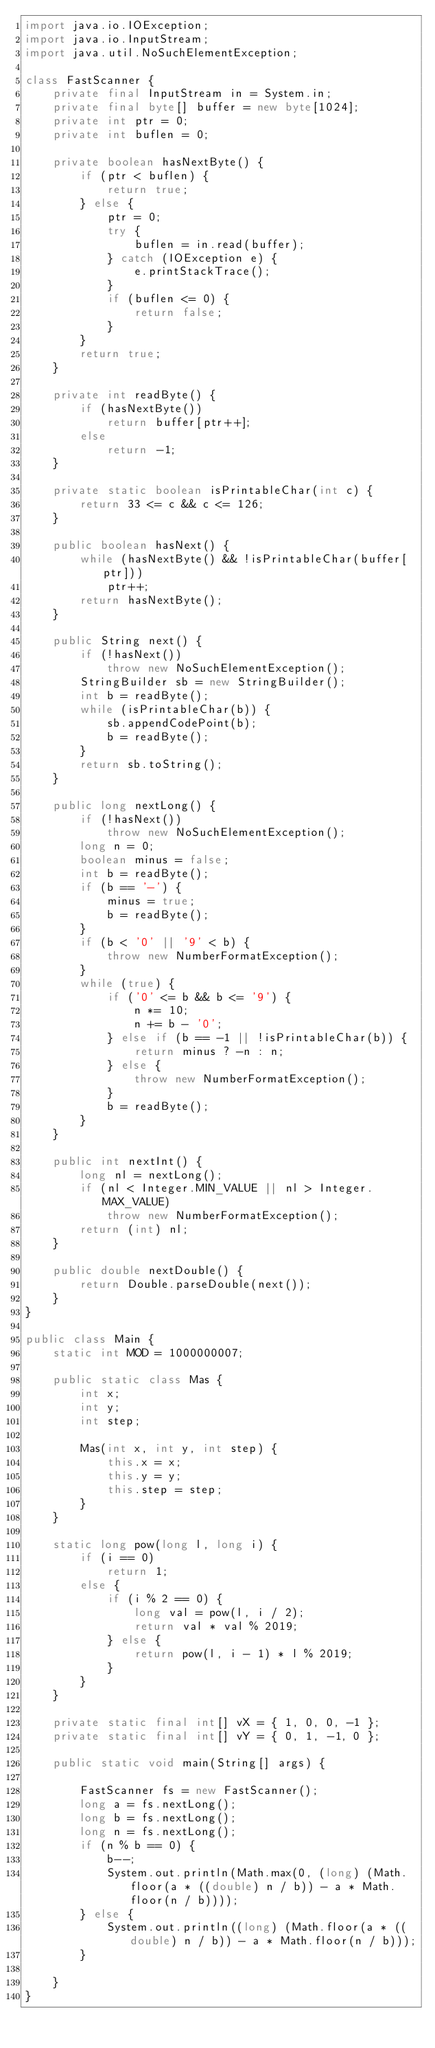Convert code to text. <code><loc_0><loc_0><loc_500><loc_500><_Java_>import java.io.IOException;
import java.io.InputStream;
import java.util.NoSuchElementException;

class FastScanner {
    private final InputStream in = System.in;
    private final byte[] buffer = new byte[1024];
    private int ptr = 0;
    private int buflen = 0;

    private boolean hasNextByte() {
        if (ptr < buflen) {
            return true;
        } else {
            ptr = 0;
            try {
                buflen = in.read(buffer);
            } catch (IOException e) {
                e.printStackTrace();
            }
            if (buflen <= 0) {
                return false;
            }
        }
        return true;
    }

    private int readByte() {
        if (hasNextByte())
            return buffer[ptr++];
        else
            return -1;
    }

    private static boolean isPrintableChar(int c) {
        return 33 <= c && c <= 126;
    }

    public boolean hasNext() {
        while (hasNextByte() && !isPrintableChar(buffer[ptr]))
            ptr++;
        return hasNextByte();
    }

    public String next() {
        if (!hasNext())
            throw new NoSuchElementException();
        StringBuilder sb = new StringBuilder();
        int b = readByte();
        while (isPrintableChar(b)) {
            sb.appendCodePoint(b);
            b = readByte();
        }
        return sb.toString();
    }

    public long nextLong() {
        if (!hasNext())
            throw new NoSuchElementException();
        long n = 0;
        boolean minus = false;
        int b = readByte();
        if (b == '-') {
            minus = true;
            b = readByte();
        }
        if (b < '0' || '9' < b) {
            throw new NumberFormatException();
        }
        while (true) {
            if ('0' <= b && b <= '9') {
                n *= 10;
                n += b - '0';
            } else if (b == -1 || !isPrintableChar(b)) {
                return minus ? -n : n;
            } else {
                throw new NumberFormatException();
            }
            b = readByte();
        }
    }

    public int nextInt() {
        long nl = nextLong();
        if (nl < Integer.MIN_VALUE || nl > Integer.MAX_VALUE)
            throw new NumberFormatException();
        return (int) nl;
    }

    public double nextDouble() {
        return Double.parseDouble(next());
    }
}

public class Main {
    static int MOD = 1000000007;

    public static class Mas {
        int x;
        int y;
        int step;

        Mas(int x, int y, int step) {
            this.x = x;
            this.y = y;
            this.step = step;
        }
    }

    static long pow(long l, long i) {
        if (i == 0)
            return 1;
        else {
            if (i % 2 == 0) {
                long val = pow(l, i / 2);
                return val * val % 2019;
            } else {
                return pow(l, i - 1) * l % 2019;
            }
        }
    }

    private static final int[] vX = { 1, 0, 0, -1 };
    private static final int[] vY = { 0, 1, -1, 0 };

    public static void main(String[] args) {

        FastScanner fs = new FastScanner();
        long a = fs.nextLong();
        long b = fs.nextLong();
        long n = fs.nextLong();
        if (n % b == 0) {
            b--;
            System.out.println(Math.max(0, (long) (Math.floor(a * ((double) n / b)) - a * Math.floor(n / b))));
        } else {
            System.out.println((long) (Math.floor(a * ((double) n / b)) - a * Math.floor(n / b)));
        }

    }
}
</code> 